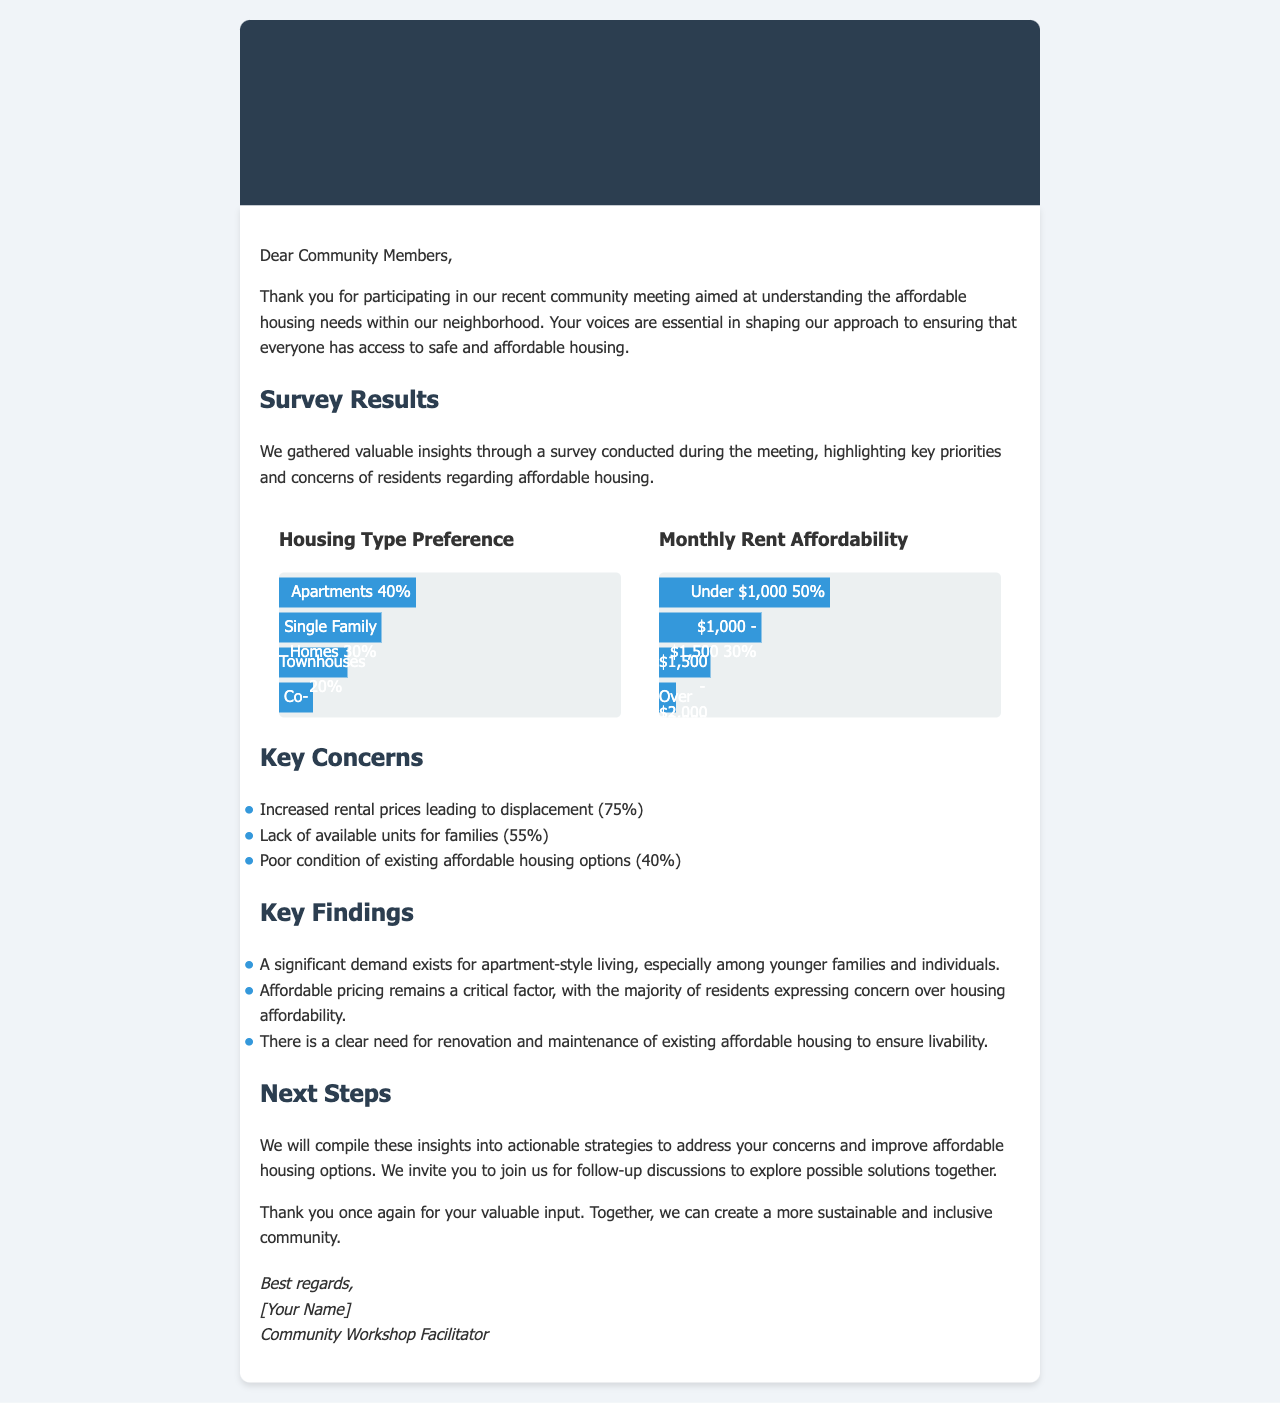What is the main focus of the community meeting? The community meeting aimed at understanding the affordable housing needs within the neighborhood.
Answer: Affordable housing needs What percentage of residents prefer apartments? The survey indicated that 40% of residents prefer apartments as their housing type.
Answer: 40% What is the most common monthly rent affordability stated by residents? The most common monthly rent affordability mentioned was under $1,000, as stated by 50% of respondents.
Answer: Under $1,000 What percentage of residents expressed concern over increased rental prices? The document states that 75% of residents are concerned about increased rental prices leading to displacement.
Answer: 75% Which housing type had the least preference according to the survey? The survey shows that co-ops received the least preference, with 10% of respondents choosing this option.
Answer: Co-ops What is one key finding about affordable housing renovation? A key finding is that there is a clear need for renovation and maintenance of existing affordable housing.
Answer: Renovation and maintenance What is the total percentage of residents who can afford monthly rent over $2,000? The document shows that 5% of residents can afford monthly rent over $2,000.
Answer: 5% What does the next steps section indicate will happen after this meeting? The next steps indicate that insights will be compiled into actionable strategies and follow-up discussions will be held.
Answer: Follow-up discussions 